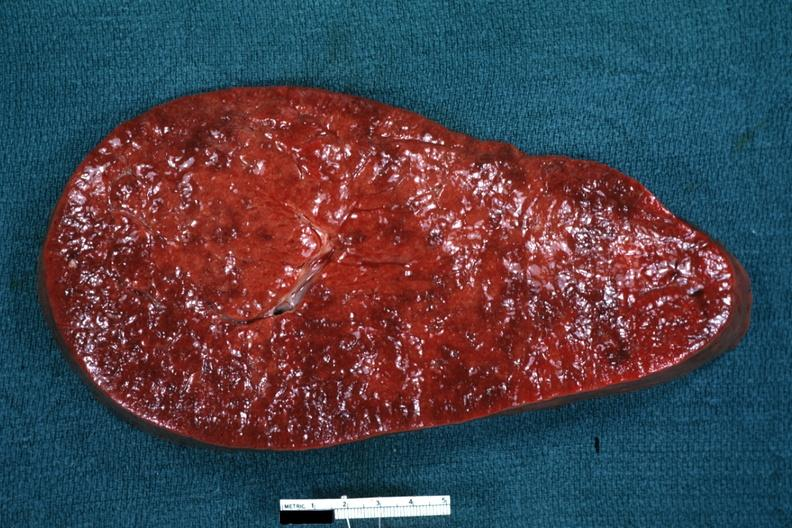where is this part in?
Answer the question using a single word or phrase. Spleen 